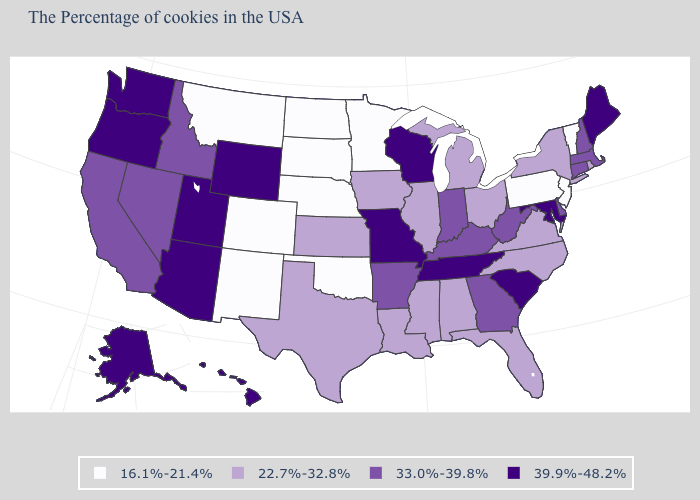What is the value of Massachusetts?
Short answer required. 33.0%-39.8%. What is the value of New Hampshire?
Keep it brief. 33.0%-39.8%. Is the legend a continuous bar?
Concise answer only. No. Which states have the lowest value in the USA?
Answer briefly. Vermont, New Jersey, Pennsylvania, Minnesota, Nebraska, Oklahoma, South Dakota, North Dakota, Colorado, New Mexico, Montana. What is the highest value in the USA?
Answer briefly. 39.9%-48.2%. Does the first symbol in the legend represent the smallest category?
Give a very brief answer. Yes. What is the value of New Jersey?
Be succinct. 16.1%-21.4%. Is the legend a continuous bar?
Keep it brief. No. What is the highest value in the USA?
Be succinct. 39.9%-48.2%. Name the states that have a value in the range 33.0%-39.8%?
Answer briefly. Massachusetts, New Hampshire, Connecticut, Delaware, West Virginia, Georgia, Kentucky, Indiana, Arkansas, Idaho, Nevada, California. Does New Jersey have the lowest value in the USA?
Quick response, please. Yes. What is the value of Virginia?
Concise answer only. 22.7%-32.8%. Which states hav the highest value in the Northeast?
Short answer required. Maine. Does the first symbol in the legend represent the smallest category?
Give a very brief answer. Yes. Does Nebraska have the lowest value in the USA?
Answer briefly. Yes. 